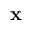Convert formula to latex. <formula><loc_0><loc_0><loc_500><loc_500>x</formula> 